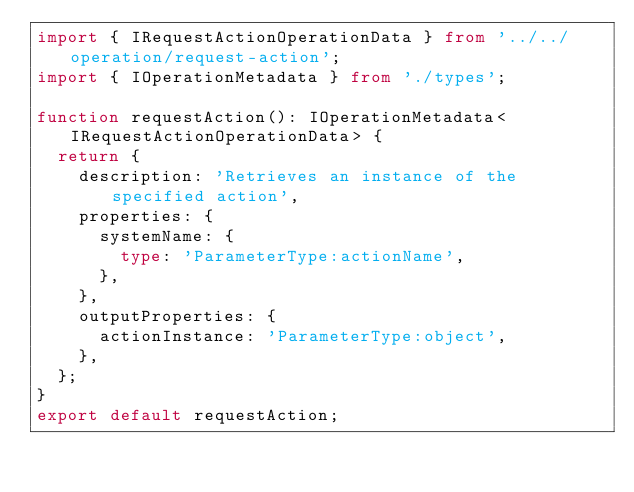Convert code to text. <code><loc_0><loc_0><loc_500><loc_500><_TypeScript_>import { IRequestActionOperationData } from '../../operation/request-action';
import { IOperationMetadata } from './types';

function requestAction(): IOperationMetadata<IRequestActionOperationData> {
  return {
    description: 'Retrieves an instance of the specified action',
    properties: {
      systemName: {
        type: 'ParameterType:actionName',
      },
    },
    outputProperties: {
      actionInstance: 'ParameterType:object',
    },
  };
}
export default requestAction;
</code> 